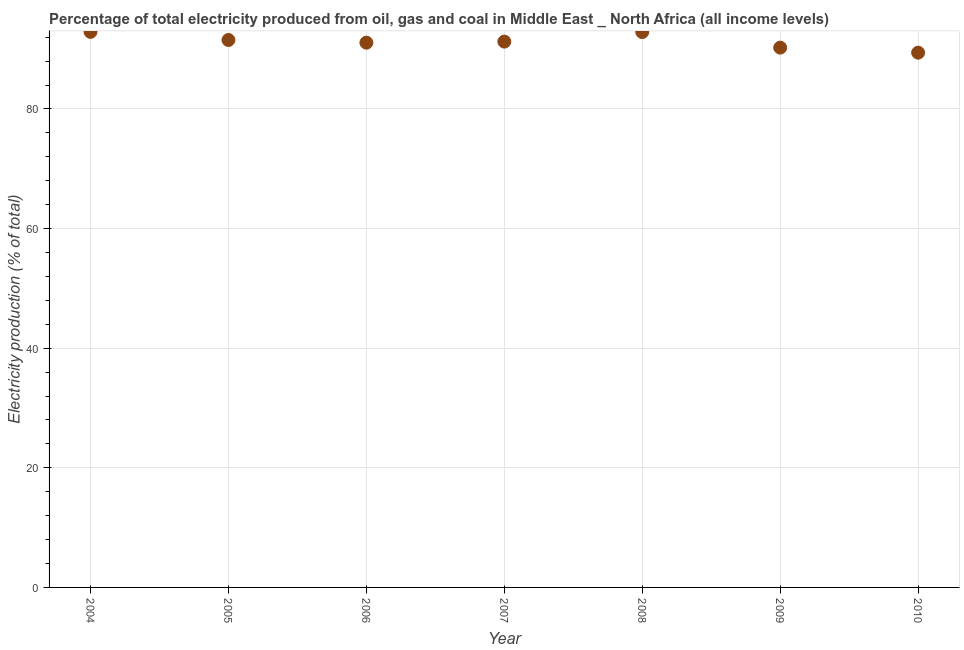What is the electricity production in 2008?
Make the answer very short. 92.86. Across all years, what is the maximum electricity production?
Provide a succinct answer. 92.89. Across all years, what is the minimum electricity production?
Keep it short and to the point. 89.41. What is the sum of the electricity production?
Offer a terse response. 639.3. What is the difference between the electricity production in 2007 and 2008?
Make the answer very short. -1.6. What is the average electricity production per year?
Offer a very short reply. 91.33. What is the median electricity production?
Your answer should be very brief. 91.26. In how many years, is the electricity production greater than 36 %?
Your answer should be compact. 7. Do a majority of the years between 2004 and 2010 (inclusive) have electricity production greater than 88 %?
Your answer should be very brief. Yes. What is the ratio of the electricity production in 2004 to that in 2008?
Ensure brevity in your answer.  1. Is the difference between the electricity production in 2008 and 2009 greater than the difference between any two years?
Ensure brevity in your answer.  No. What is the difference between the highest and the second highest electricity production?
Offer a very short reply. 0.03. What is the difference between the highest and the lowest electricity production?
Offer a very short reply. 3.48. In how many years, is the electricity production greater than the average electricity production taken over all years?
Ensure brevity in your answer.  3. How many dotlines are there?
Your answer should be compact. 1. What is the difference between two consecutive major ticks on the Y-axis?
Ensure brevity in your answer.  20. What is the title of the graph?
Ensure brevity in your answer.  Percentage of total electricity produced from oil, gas and coal in Middle East _ North Africa (all income levels). What is the label or title of the X-axis?
Provide a short and direct response. Year. What is the label or title of the Y-axis?
Keep it short and to the point. Electricity production (% of total). What is the Electricity production (% of total) in 2004?
Provide a succinct answer. 92.89. What is the Electricity production (% of total) in 2005?
Provide a short and direct response. 91.53. What is the Electricity production (% of total) in 2006?
Provide a succinct answer. 91.08. What is the Electricity production (% of total) in 2007?
Provide a short and direct response. 91.26. What is the Electricity production (% of total) in 2008?
Provide a short and direct response. 92.86. What is the Electricity production (% of total) in 2009?
Offer a very short reply. 90.25. What is the Electricity production (% of total) in 2010?
Offer a very short reply. 89.41. What is the difference between the Electricity production (% of total) in 2004 and 2005?
Your answer should be very brief. 1.36. What is the difference between the Electricity production (% of total) in 2004 and 2006?
Your answer should be compact. 1.81. What is the difference between the Electricity production (% of total) in 2004 and 2007?
Provide a short and direct response. 1.63. What is the difference between the Electricity production (% of total) in 2004 and 2008?
Provide a short and direct response. 0.03. What is the difference between the Electricity production (% of total) in 2004 and 2009?
Offer a very short reply. 2.64. What is the difference between the Electricity production (% of total) in 2004 and 2010?
Offer a very short reply. 3.48. What is the difference between the Electricity production (% of total) in 2005 and 2006?
Your response must be concise. 0.45. What is the difference between the Electricity production (% of total) in 2005 and 2007?
Provide a short and direct response. 0.27. What is the difference between the Electricity production (% of total) in 2005 and 2008?
Provide a succinct answer. -1.33. What is the difference between the Electricity production (% of total) in 2005 and 2009?
Make the answer very short. 1.28. What is the difference between the Electricity production (% of total) in 2005 and 2010?
Your answer should be very brief. 2.12. What is the difference between the Electricity production (% of total) in 2006 and 2007?
Offer a very short reply. -0.18. What is the difference between the Electricity production (% of total) in 2006 and 2008?
Keep it short and to the point. -1.78. What is the difference between the Electricity production (% of total) in 2006 and 2009?
Make the answer very short. 0.83. What is the difference between the Electricity production (% of total) in 2006 and 2010?
Provide a succinct answer. 1.67. What is the difference between the Electricity production (% of total) in 2007 and 2008?
Your answer should be very brief. -1.6. What is the difference between the Electricity production (% of total) in 2007 and 2009?
Your response must be concise. 1.01. What is the difference between the Electricity production (% of total) in 2007 and 2010?
Your answer should be compact. 1.85. What is the difference between the Electricity production (% of total) in 2008 and 2009?
Ensure brevity in your answer.  2.61. What is the difference between the Electricity production (% of total) in 2008 and 2010?
Ensure brevity in your answer.  3.45. What is the difference between the Electricity production (% of total) in 2009 and 2010?
Offer a terse response. 0.84. What is the ratio of the Electricity production (% of total) in 2004 to that in 2005?
Offer a very short reply. 1.01. What is the ratio of the Electricity production (% of total) in 2004 to that in 2006?
Provide a short and direct response. 1.02. What is the ratio of the Electricity production (% of total) in 2004 to that in 2007?
Your answer should be compact. 1.02. What is the ratio of the Electricity production (% of total) in 2004 to that in 2008?
Provide a succinct answer. 1. What is the ratio of the Electricity production (% of total) in 2004 to that in 2009?
Give a very brief answer. 1.03. What is the ratio of the Electricity production (% of total) in 2004 to that in 2010?
Provide a succinct answer. 1.04. What is the ratio of the Electricity production (% of total) in 2005 to that in 2007?
Offer a terse response. 1. What is the ratio of the Electricity production (% of total) in 2005 to that in 2010?
Your response must be concise. 1.02. What is the ratio of the Electricity production (% of total) in 2006 to that in 2008?
Your answer should be compact. 0.98. What is the ratio of the Electricity production (% of total) in 2006 to that in 2010?
Provide a succinct answer. 1.02. What is the ratio of the Electricity production (% of total) in 2007 to that in 2009?
Keep it short and to the point. 1.01. What is the ratio of the Electricity production (% of total) in 2008 to that in 2010?
Provide a succinct answer. 1.04. 